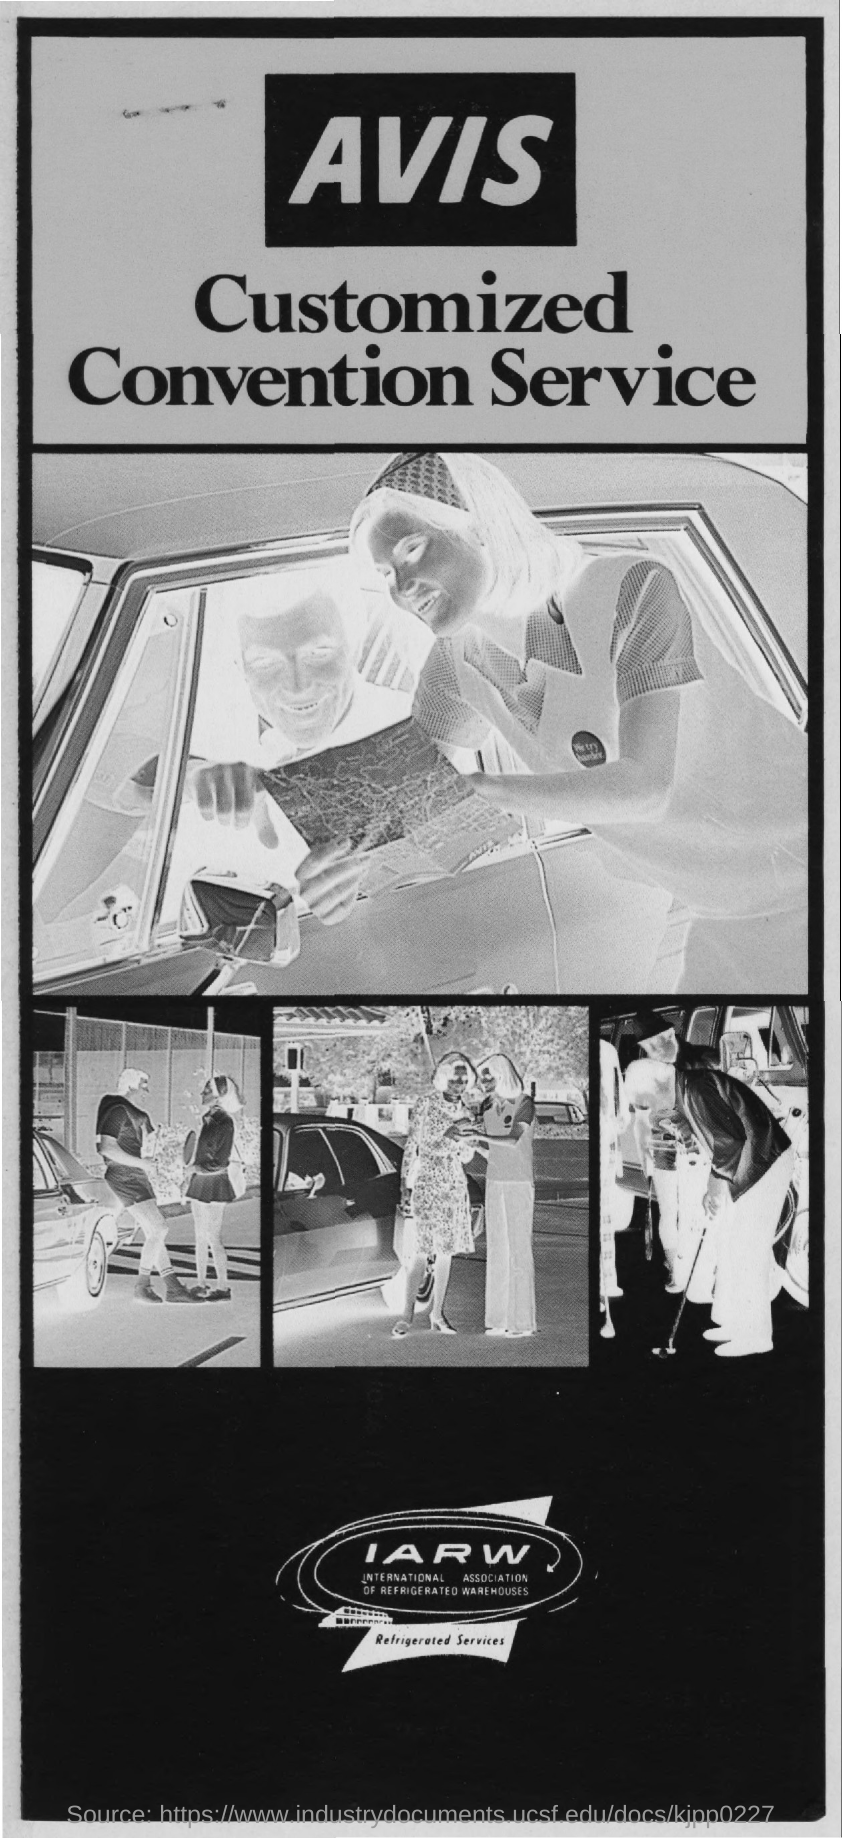What does IARW stands for?
Provide a short and direct response. INTERNATIONAL ASSOCIATION OF REFRIGERATED WAREHOUSES. What is this services about?
Offer a terse response. Refrigerated Services. 